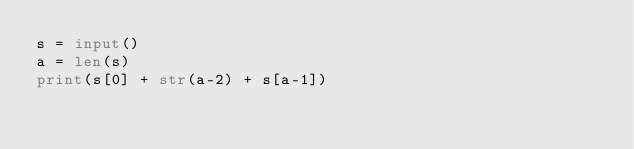<code> <loc_0><loc_0><loc_500><loc_500><_Python_>s = input()
a = len(s)
print(s[0] + str(a-2) + s[a-1])</code> 